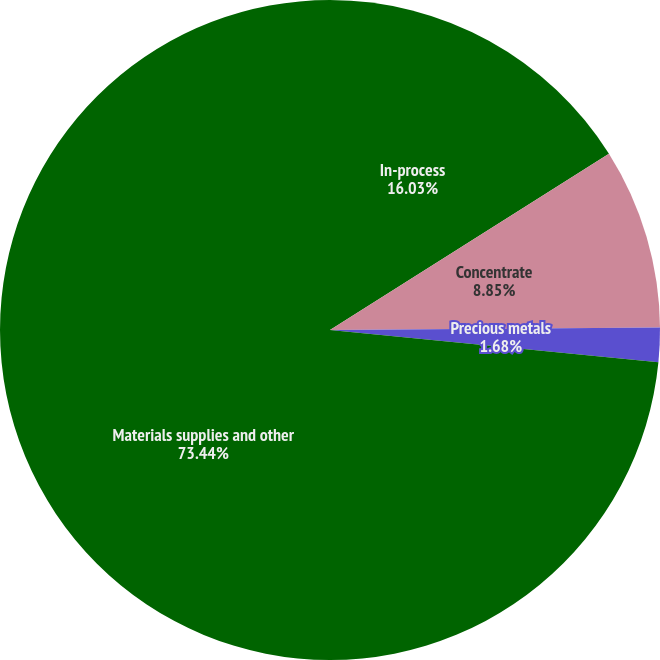Convert chart. <chart><loc_0><loc_0><loc_500><loc_500><pie_chart><fcel>In-process<fcel>Concentrate<fcel>Precious metals<fcel>Materials supplies and other<nl><fcel>16.03%<fcel>8.85%<fcel>1.68%<fcel>73.44%<nl></chart> 